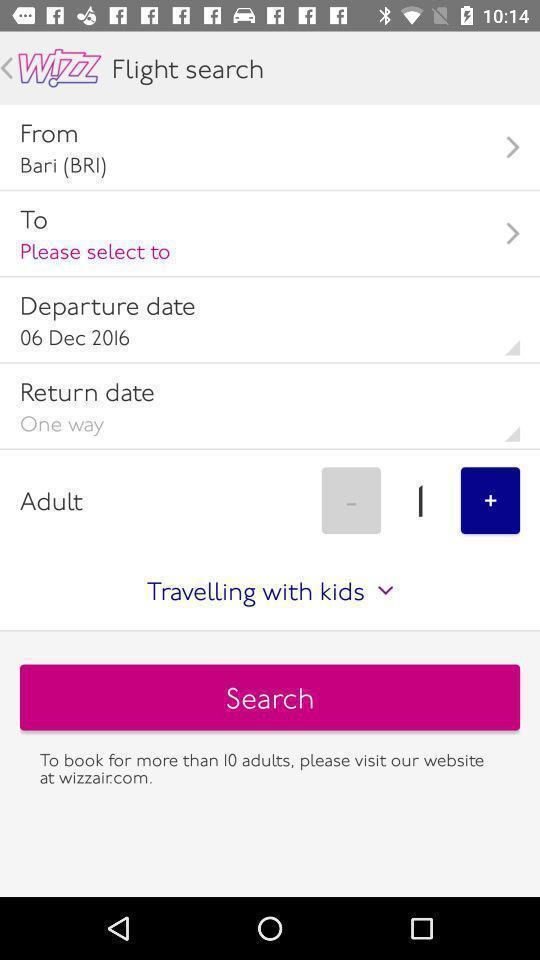Explain what's happening in this screen capture. Search page for searching a flights. 